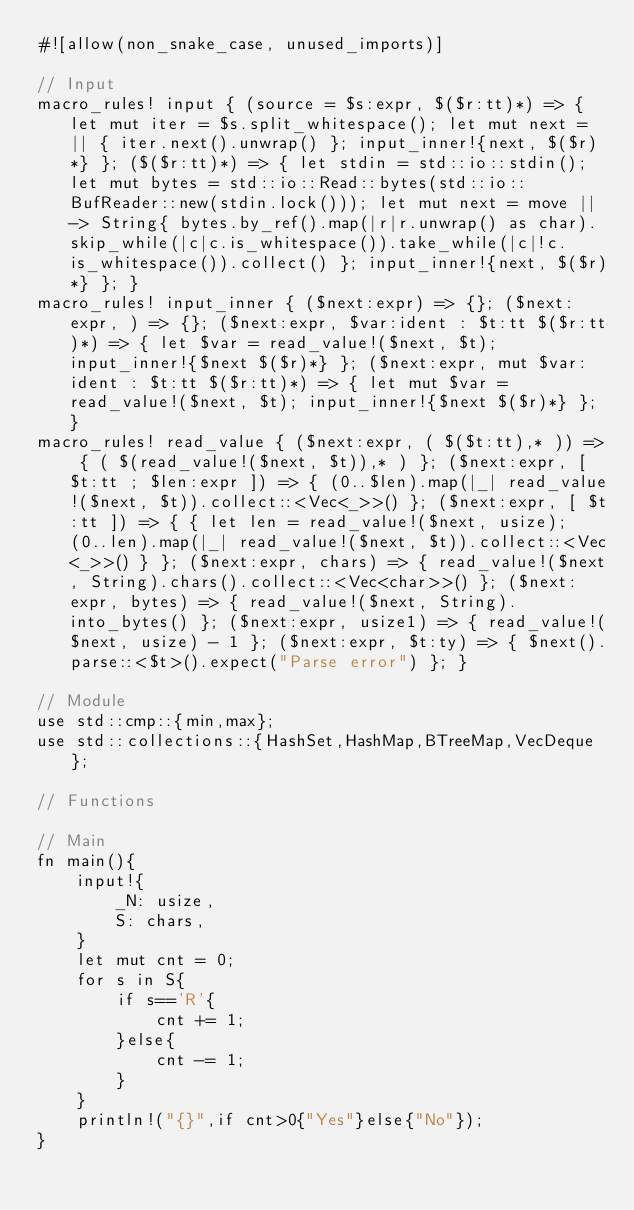<code> <loc_0><loc_0><loc_500><loc_500><_Rust_>#![allow(non_snake_case, unused_imports)]

// Input
macro_rules! input { (source = $s:expr, $($r:tt)*) => { let mut iter = $s.split_whitespace(); let mut next = || { iter.next().unwrap() }; input_inner!{next, $($r)*} }; ($($r:tt)*) => { let stdin = std::io::stdin(); let mut bytes = std::io::Read::bytes(std::io::BufReader::new(stdin.lock())); let mut next = move || -> String{ bytes.by_ref().map(|r|r.unwrap() as char).skip_while(|c|c.is_whitespace()).take_while(|c|!c.is_whitespace()).collect() }; input_inner!{next, $($r)*} }; }
macro_rules! input_inner { ($next:expr) => {}; ($next:expr, ) => {}; ($next:expr, $var:ident : $t:tt $($r:tt)*) => { let $var = read_value!($next, $t); input_inner!{$next $($r)*} }; ($next:expr, mut $var:ident : $t:tt $($r:tt)*) => { let mut $var = read_value!($next, $t); input_inner!{$next $($r)*} }; }
macro_rules! read_value { ($next:expr, ( $($t:tt),* )) => { ( $(read_value!($next, $t)),* ) }; ($next:expr, [ $t:tt ; $len:expr ]) => { (0..$len).map(|_| read_value!($next, $t)).collect::<Vec<_>>() }; ($next:expr, [ $t:tt ]) => { { let len = read_value!($next, usize); (0..len).map(|_| read_value!($next, $t)).collect::<Vec<_>>() } }; ($next:expr, chars) => { read_value!($next, String).chars().collect::<Vec<char>>() }; ($next:expr, bytes) => { read_value!($next, String).into_bytes() }; ($next:expr, usize1) => { read_value!($next, usize) - 1 }; ($next:expr, $t:ty) => { $next().parse::<$t>().expect("Parse error") }; }

// Module
use std::cmp::{min,max};
use std::collections::{HashSet,HashMap,BTreeMap,VecDeque};

// Functions

// Main
fn main(){
    input!{
        _N: usize,
        S: chars,
    }
    let mut cnt = 0;
    for s in S{
        if s=='R'{
            cnt += 1;
        }else{
            cnt -= 1;
        }
    }
    println!("{}",if cnt>0{"Yes"}else{"No"});
}</code> 